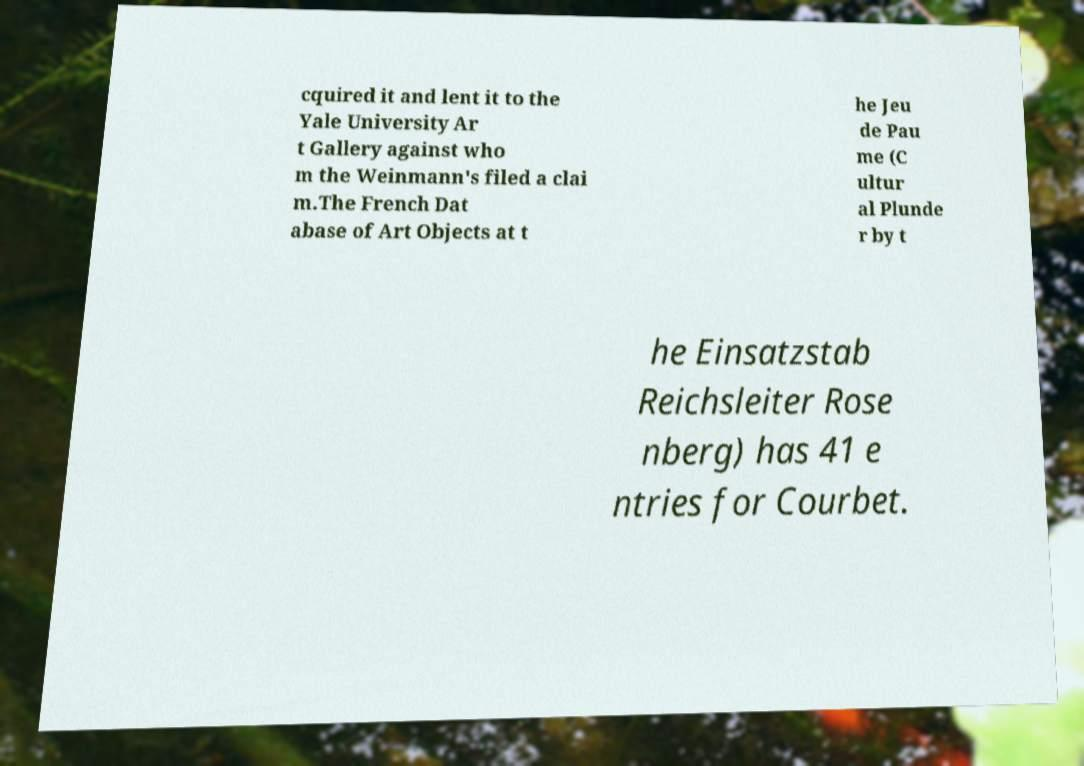Could you assist in decoding the text presented in this image and type it out clearly? cquired it and lent it to the Yale University Ar t Gallery against who m the Weinmann's filed a clai m.The French Dat abase of Art Objects at t he Jeu de Pau me (C ultur al Plunde r by t he Einsatzstab Reichsleiter Rose nberg) has 41 e ntries for Courbet. 